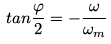<formula> <loc_0><loc_0><loc_500><loc_500>t a n \frac { \varphi } { 2 } = - \frac { \omega } { \omega _ { m } }</formula> 